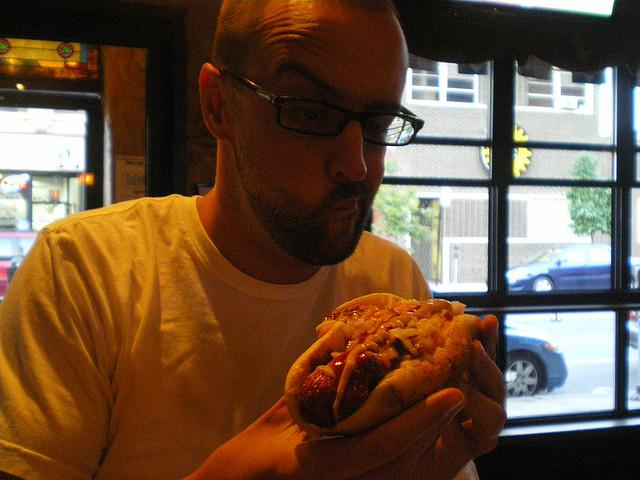Why does he have the huge sandwich?

Choices:
A) is sharing
B) overloaded it
C) is hungry
D) not his is hungry 